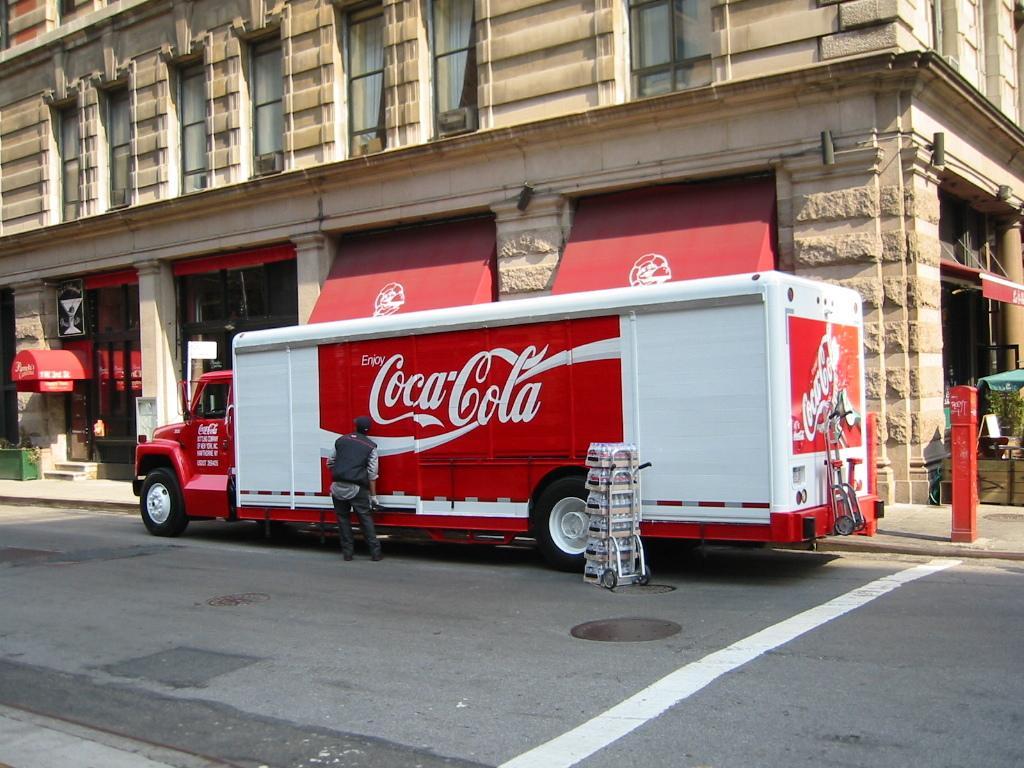Could you give a brief overview of what you see in this image? In this image there is a truck on a road, beside the truck there is a person standing, in the background there is a building. 